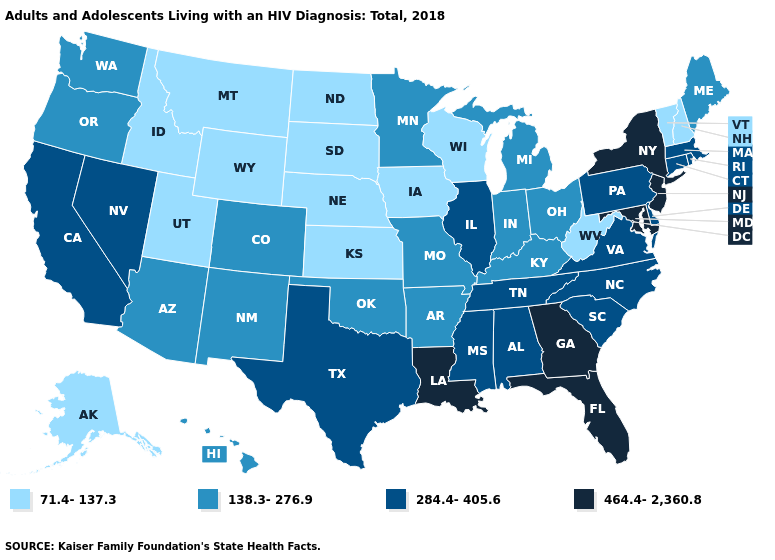What is the value of Wisconsin?
Be succinct. 71.4-137.3. What is the highest value in the MidWest ?
Write a very short answer. 284.4-405.6. What is the value of South Dakota?
Give a very brief answer. 71.4-137.3. Name the states that have a value in the range 284.4-405.6?
Short answer required. Alabama, California, Connecticut, Delaware, Illinois, Massachusetts, Mississippi, Nevada, North Carolina, Pennsylvania, Rhode Island, South Carolina, Tennessee, Texas, Virginia. What is the value of Washington?
Give a very brief answer. 138.3-276.9. Does the map have missing data?
Answer briefly. No. What is the value of Georgia?
Write a very short answer. 464.4-2,360.8. What is the highest value in states that border Iowa?
Answer briefly. 284.4-405.6. Name the states that have a value in the range 464.4-2,360.8?
Concise answer only. Florida, Georgia, Louisiana, Maryland, New Jersey, New York. Name the states that have a value in the range 464.4-2,360.8?
Concise answer only. Florida, Georgia, Louisiana, Maryland, New Jersey, New York. What is the value of Michigan?
Concise answer only. 138.3-276.9. Name the states that have a value in the range 71.4-137.3?
Short answer required. Alaska, Idaho, Iowa, Kansas, Montana, Nebraska, New Hampshire, North Dakota, South Dakota, Utah, Vermont, West Virginia, Wisconsin, Wyoming. What is the lowest value in the MidWest?
Answer briefly. 71.4-137.3. What is the lowest value in the MidWest?
Write a very short answer. 71.4-137.3. Which states have the highest value in the USA?
Give a very brief answer. Florida, Georgia, Louisiana, Maryland, New Jersey, New York. 